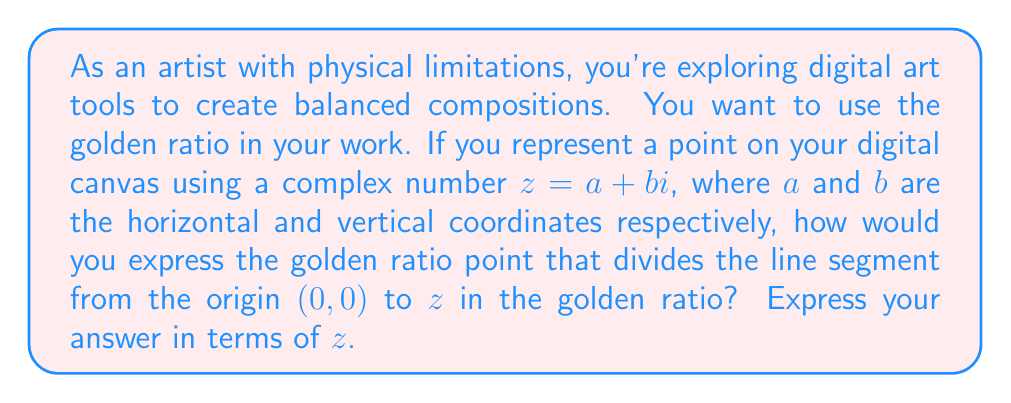Teach me how to tackle this problem. Let's approach this step-by-step:

1) The golden ratio, often denoted by $\phi$, is approximately 1.618033988749895. It can be expressed as:

   $$\phi = \frac{1 + \sqrt{5}}{2}$$

2) In a line segment divided according to the golden ratio, the ratio of the longer part to the shorter part is equal to the ratio of the whole segment to the longer part. If we denote the golden ratio point as $g$, then:

   $$\frac{|z|}{|g|} = \frac{|g|}{|z-g|} = \phi$$

3) From this, we can deduce that:

   $$g = \frac{z}{\phi}$$

4) To express this using complex number operations, we need to multiply $z$ by the reciprocal of $\phi$:

   $$g = z \cdot \frac{1}{\phi} = z \cdot \frac{2}{1 + \sqrt{5}}$$

5) We can rationalize the denominator:

   $$g = z \cdot \frac{2}{1 + \sqrt{5}} \cdot \frac{1 - \sqrt{5}}{1 - \sqrt{5}}$$

6) Simplifying:

   $$g = z \cdot \frac{2(1 - \sqrt{5})}{(1 + \sqrt{5})(1 - \sqrt{5})} = z \cdot \frac{2(1 - \sqrt{5})}{1 - 5} = z \cdot \frac{2(\sqrt{5} - 1)}{4}$$

7) Further simplifying:

   $$g = z \cdot \frac{\sqrt{5} - 1}{2}$$

This expression represents the point that divides the line segment from the origin to $z$ in the golden ratio.
Answer: $g = z \cdot \frac{\sqrt{5} - 1}{2}$ 